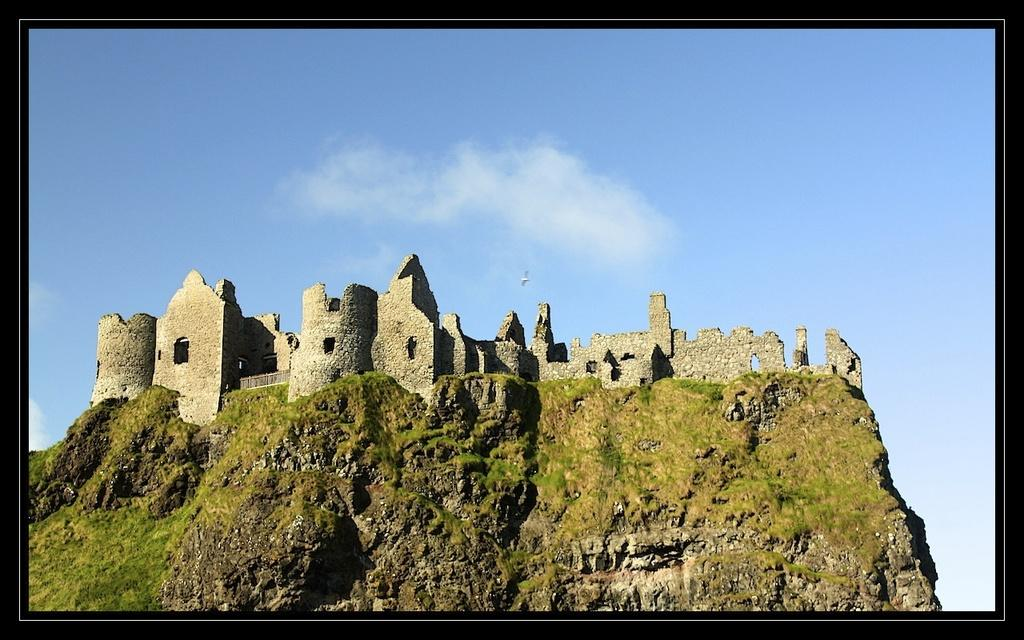What can be seen in the background of the image? There is a clear blue sky in the background of the image. What is the main structure in the image? There is a castle in the image. Are there any animals visible in the image? It appears that there is a bird in the air in the image. What type of substance is being used to create the castle in the image? There is no indication in the image that the castle is being created or that any substance is being used. The castle appears to be a solid structure. 